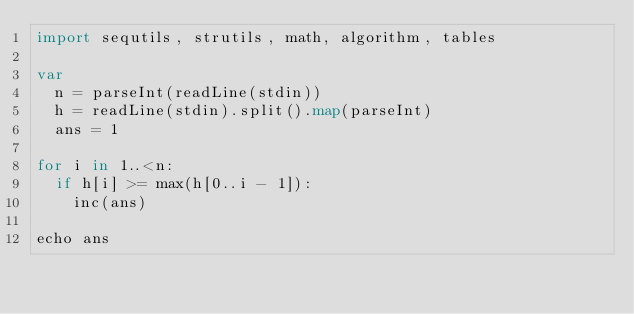Convert code to text. <code><loc_0><loc_0><loc_500><loc_500><_Nim_>import sequtils, strutils, math, algorithm, tables

var
  n = parseInt(readLine(stdin))
  h = readLine(stdin).split().map(parseInt)
  ans = 1

for i in 1..<n:
  if h[i] >= max(h[0..i - 1]):
    inc(ans)

echo ans</code> 